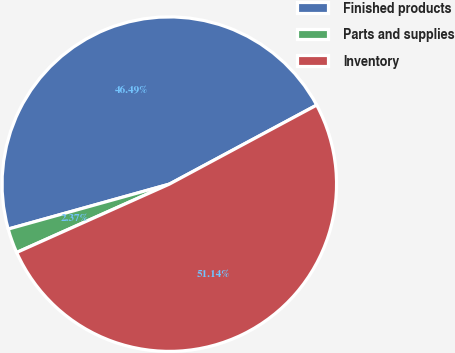Convert chart. <chart><loc_0><loc_0><loc_500><loc_500><pie_chart><fcel>Finished products<fcel>Parts and supplies<fcel>Inventory<nl><fcel>46.49%<fcel>2.37%<fcel>51.14%<nl></chart> 